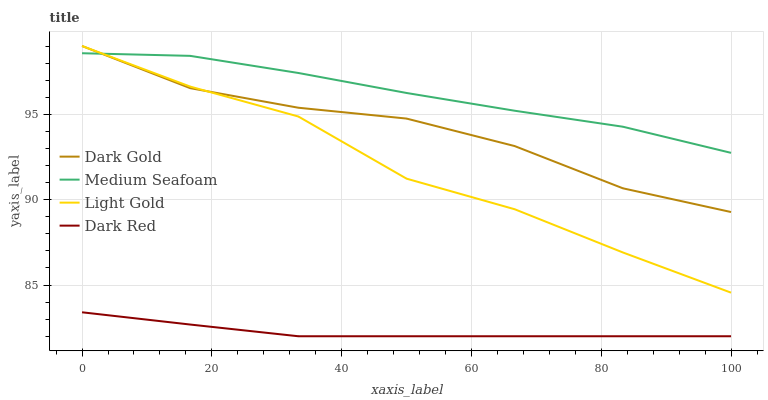Does Light Gold have the minimum area under the curve?
Answer yes or no. No. Does Light Gold have the maximum area under the curve?
Answer yes or no. No. Is Medium Seafoam the smoothest?
Answer yes or no. No. Is Medium Seafoam the roughest?
Answer yes or no. No. Does Light Gold have the lowest value?
Answer yes or no. No. Does Medium Seafoam have the highest value?
Answer yes or no. No. Is Dark Red less than Light Gold?
Answer yes or no. Yes. Is Dark Gold greater than Dark Red?
Answer yes or no. Yes. Does Dark Red intersect Light Gold?
Answer yes or no. No. 